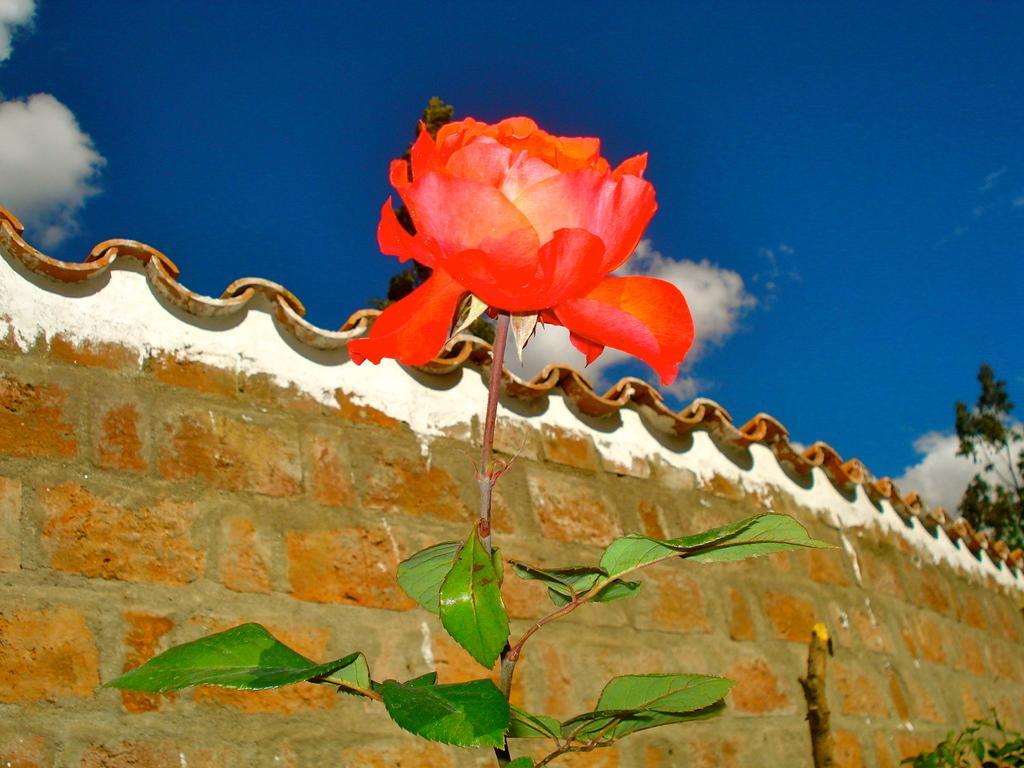Please provide a concise description of this image. In this image we can see a rose flower with stem and leaves. In the back there is a brick wall. In the background there is sky with clouds. On the right side we can see a tree. 